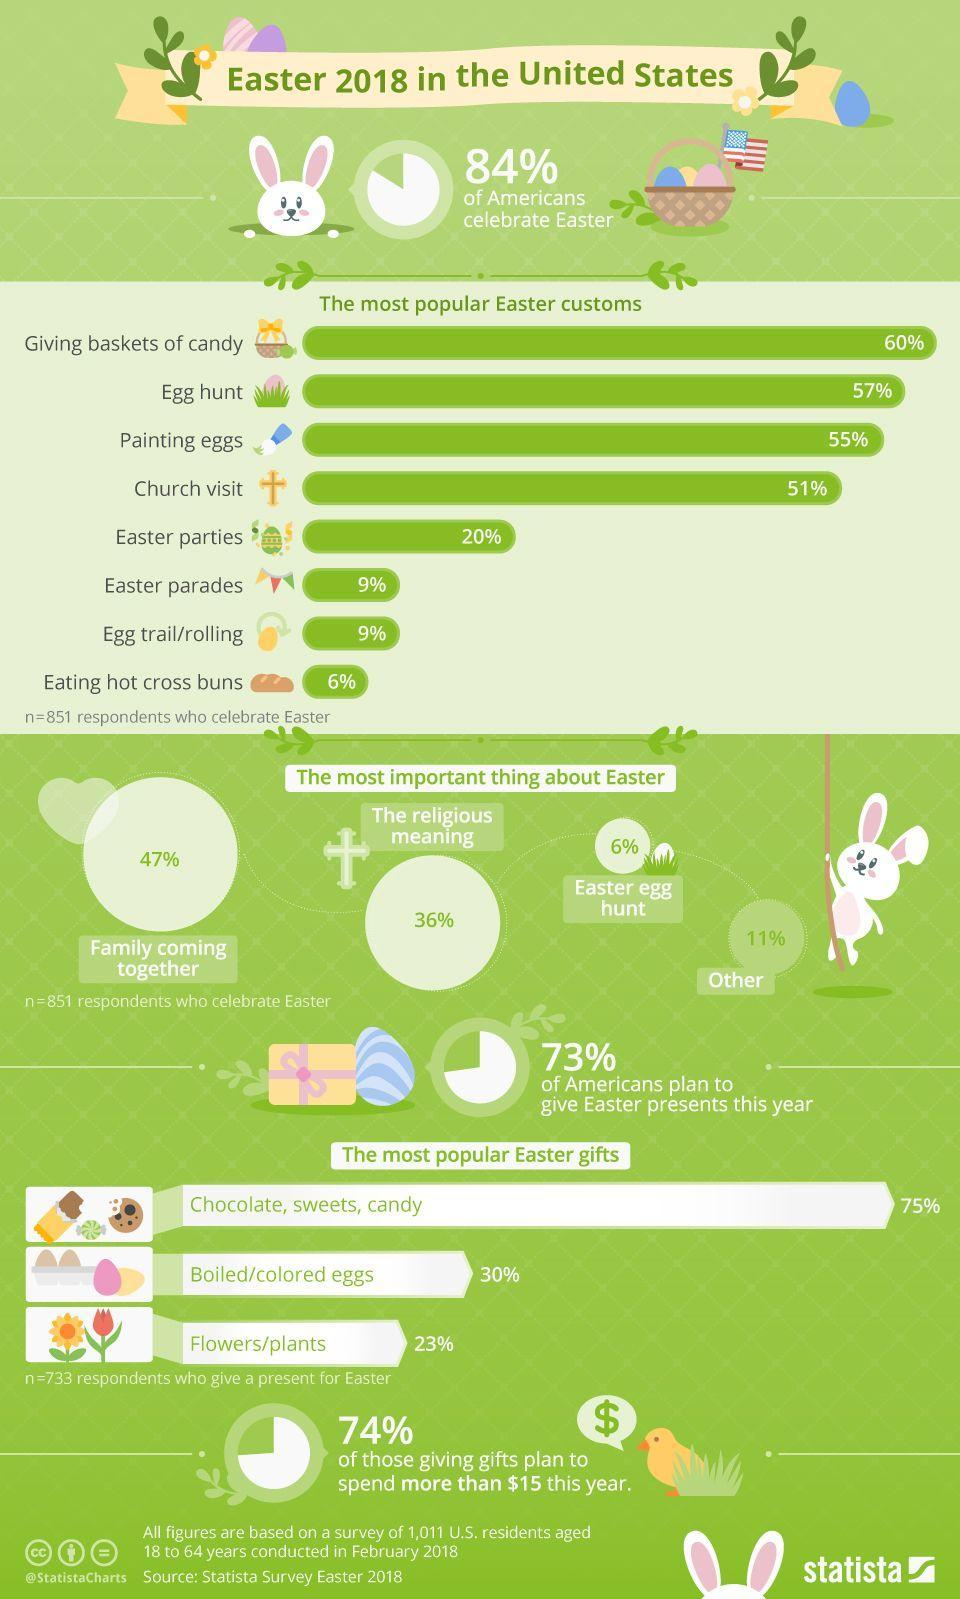How many Easter customs are being celebrated in America?
Answer the question with a short phrase. 8 What percentage of Americans does not plan to give Easter presents in 2018? 27 Which is the average popular Easter Gift? Boiled/colored Eggs What percentage of Americans does not celebrates Egg hunt? 94 What percentage of Americans give religious meaning to Easter? 36% Which is the second most popular Easter custom? Egg Hunt What percentage of Americans does not celebrate Easter? 16 How many different Easter Gifts are listed in the info graphic? 3 How many Easter customs are having popularity more than 50 %? 4 How many American families go for family get together for Easter? 47% 